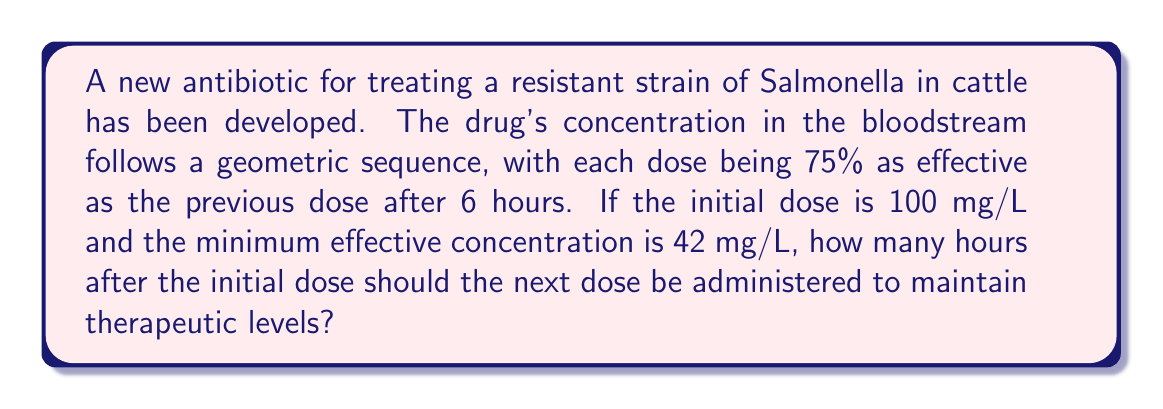Can you answer this question? Let's approach this step-by-step:

1) We have a geometric sequence where each term is 75% of the previous term after 6 hours.
   The common ratio for 6 hours is $r = 0.75$

2) We need to find the common ratio for 1 hour:
   $$r_1 = 0.75^{\frac{1}{6}} \approx 0.9534$$

3) Let's define our geometric sequence:
   $$a_n = 100 \cdot (0.9534)^n$$
   where $n$ is the number of hours and 100 is the initial concentration.

4) We need to find $n$ when $a_n = 42$ (the minimum effective concentration):
   $$42 = 100 \cdot (0.9534)^n$$

5) Dividing both sides by 100:
   $$0.42 = (0.9534)^n$$

6) Taking the natural log of both sides:
   $$\ln(0.42) = n \cdot \ln(0.9534)$$

7) Solving for $n$:
   $$n = \frac{\ln(0.42)}{\ln(0.9534)} \approx 18.06$$

8) Rounding down to ensure we don't go below the minimum effective concentration:
   $n = 18$ hours
Answer: 18 hours 